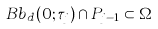Convert formula to latex. <formula><loc_0><loc_0><loc_500><loc_500>\ B b _ { d } ( 0 ; \tau _ { j } ) \cap P _ { j - 1 } \subset \Omega</formula> 